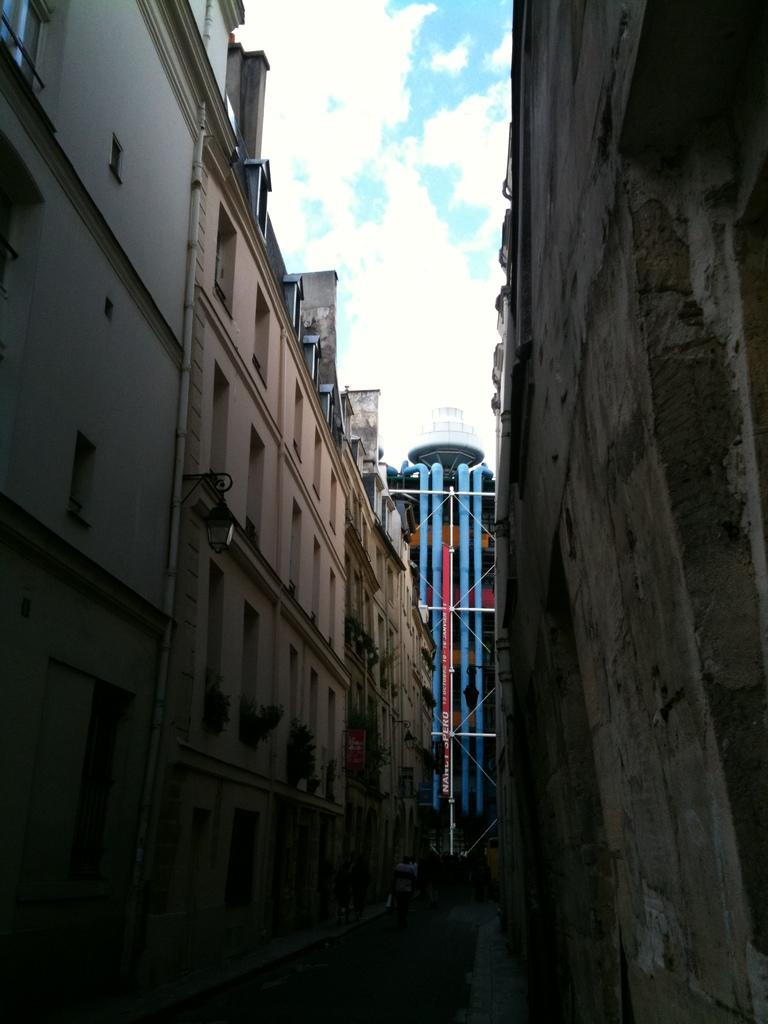What color are the pipes visible in the background of the image? The pipes in the background of the image are blue. What structures can be seen on both sides of the image? There are buildings on both sides of the image. What is visible at the top of the image? The sky is visible at the top of the image. What can be observed in the sky in the image? Clouds are present in the sky. What type of rod is being used for fishing in the middle of the image? There is no rod or fishing activity present in the image. What hobbies are the people in the image engaged in? The image does not show any people, so their hobbies cannot be determined. 